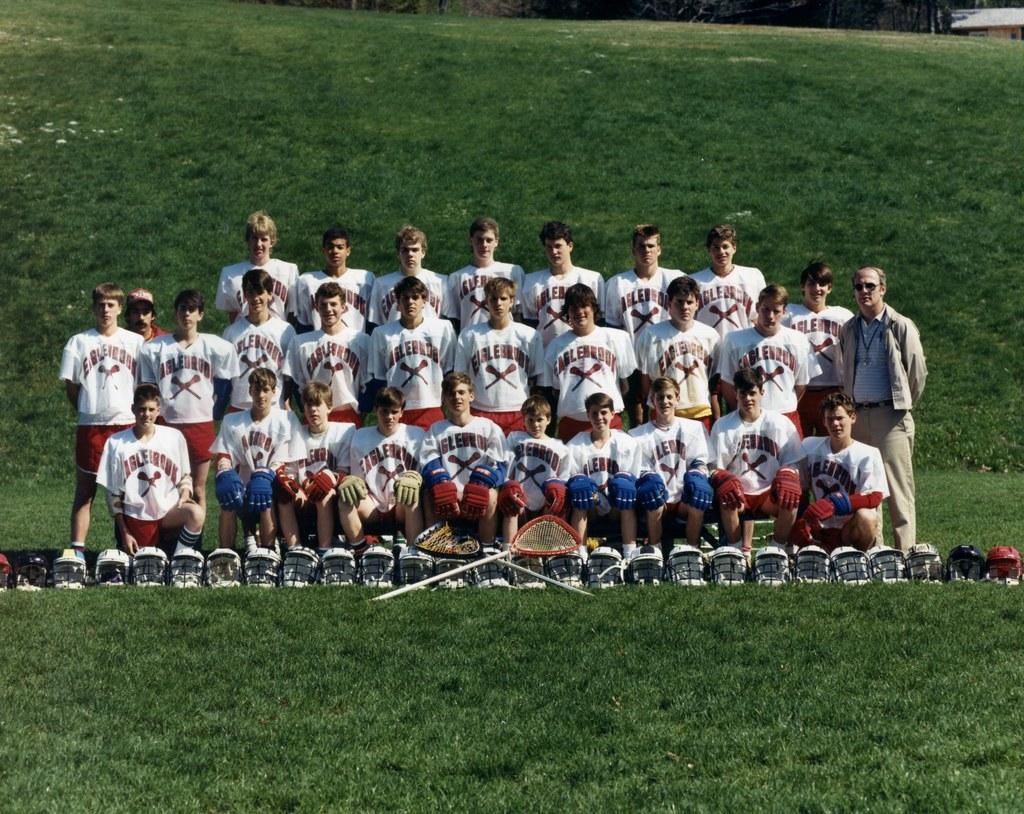How would you summarize this image in a sentence or two? In the picture we can see two rows of people are standing in the sports wear on the grass surface and in front of them, we can see some people are sitting on the grass surface and in the background also we can see the grass surface. 